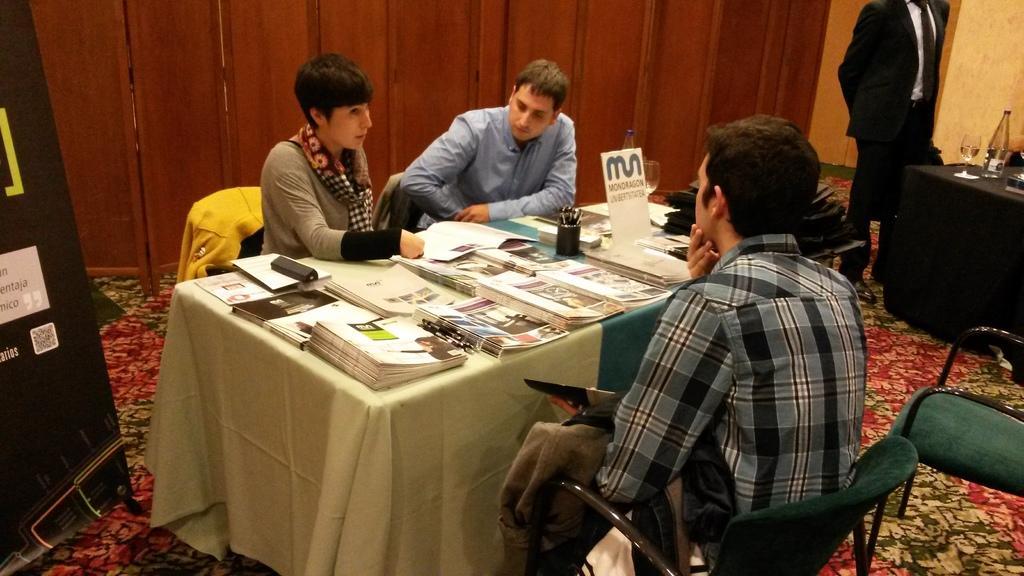Could you give a brief overview of what you see in this image? In this image I can see few people are sitting on chairs and a person is standing. Here on this table I can see number of books and a glass and a bottle. 